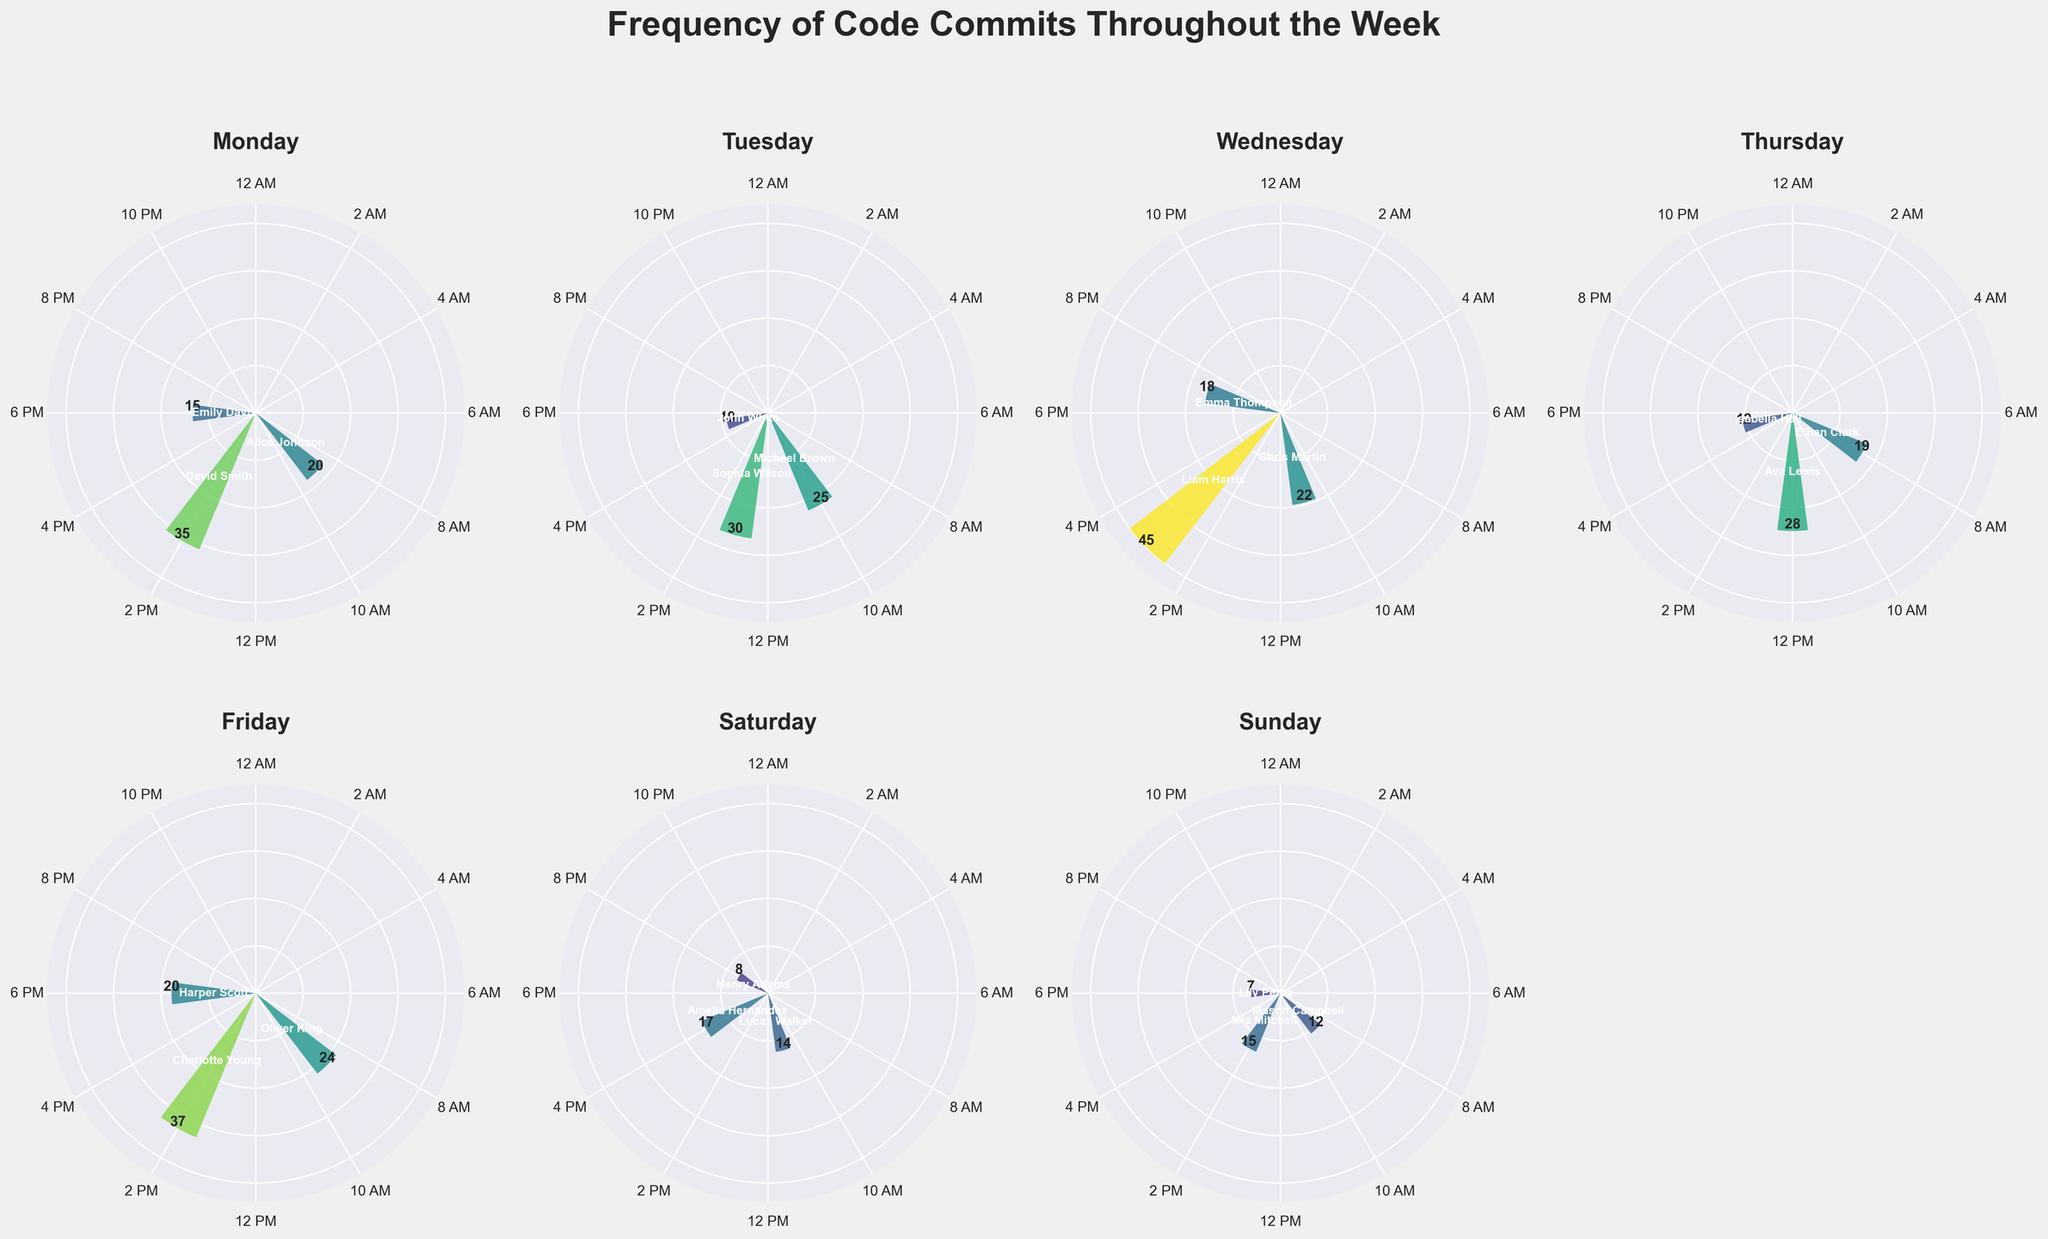What is the title of the subplot figure? The title is written at the top of the figure in large, bold text, summarizing what the entire plot represents.
Answer: Frequency of Code Commits Throughout the Week Which day has the highest number of commits in a single hour? By examining each subplot, note the highest bar; Wednesday at 3 PM has the highest bar with 45 commits.
Answer: Wednesday What time of day does Alice Johnson commit most frequently? By looking at the subplot for Monday and the labels, Alice Johnson has her highest commit frequency at 9 AM.
Answer: 9 AM On which days are there no code commits in the evening (after 6 PM)? Review the subplots for each day and identify which ones have no bars after 6 PM. There are no commits after 6 PM on Tuesday, Saturday, and Sunday.
Answer: Tuesday, Saturday, Sunday Who made the highest number of commits on Friday, and how many? In the Friday subplot, the highest bar is at 2 PM. The label on this bar indicates both the developer and the number of commits. Charlotte Young made 37 commits.
Answer: Charlotte Young, 37 What times of the day are most common for code commits throughout the week? Look at the subplots and check which hour intervals commonly show high bars across multiple days. 9 AM, 2 PM, and 5 PM are often common for multiple days.
Answer: 9 AM, 2 PM, 5 PM How many commits did David Smith make on Monday compared to Ethan Clark on Thursday? Look at Monday and Thursday subplots, find David Smith at 2 PM on Monday with 35 commits, and Ethan Clark at 8 AM on Thursday has 19 commits. Compare the two numbers.
Answer: David Smith: 35, Ethan Clark: 19 Which day has the lowest total number of commits? Sum the commits for each day (by adding heights of the bars in the subplot). Sunday has the lowest sum of commits.
Answer: Sunday Compare Wednesday and Friday based on the average number of commits per hour of commits. Which day has a higher average? Sum the commits for each day: Wednesday (22+45+18=85), Friday (24+37+20=81). Divide by the number of active hours: Wednesday (85/3) and Friday (81/3).
Answer: Wednesday: 28.33, Friday: 27 Who has the least number of commits among all developers? Look at all bars and find the smallest value labeled with a developer's name. Lily Perez has 7 commits on Sunday at 6 PM.
Answer: Lily Perez 